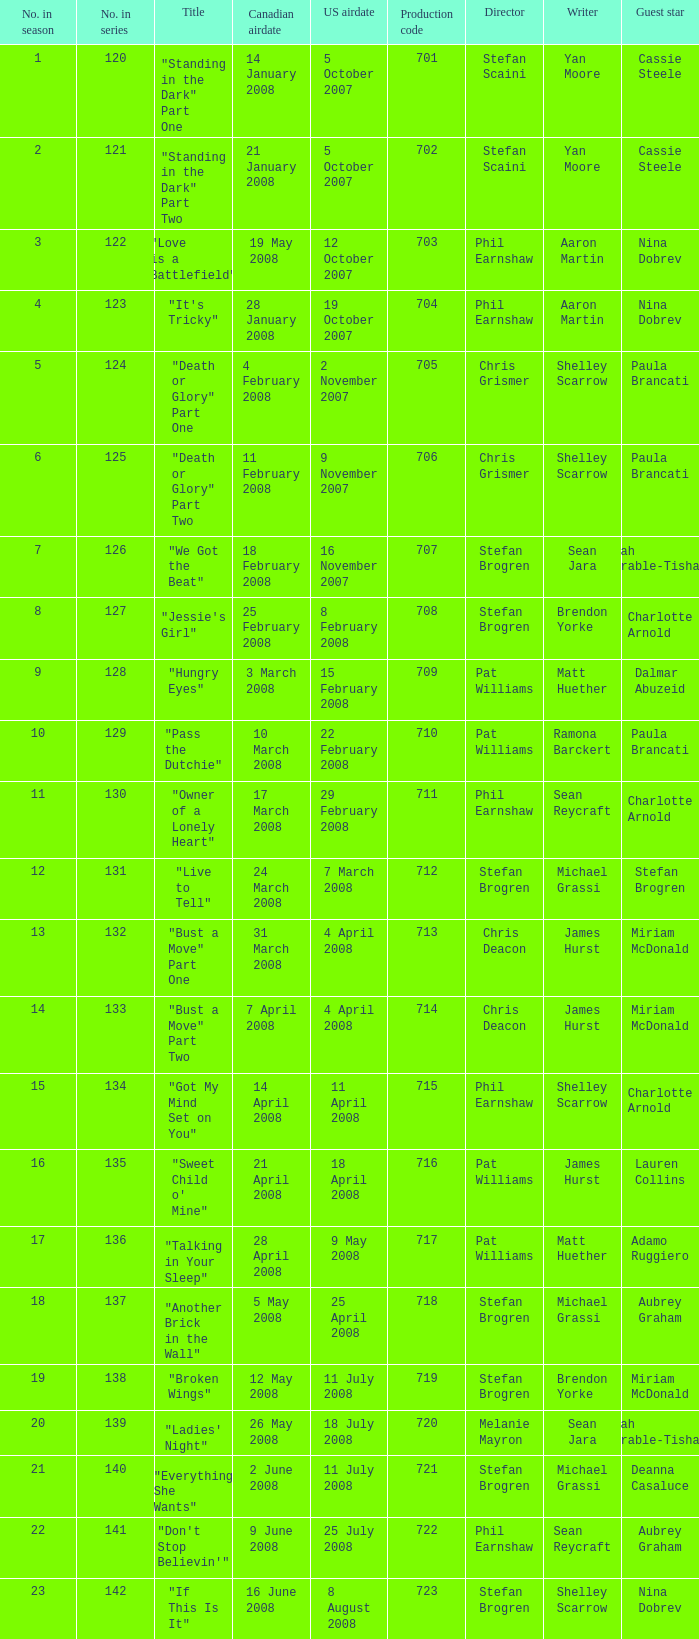The U.S. airdate of 4 april 2008 had a production code of what? 714.0. 